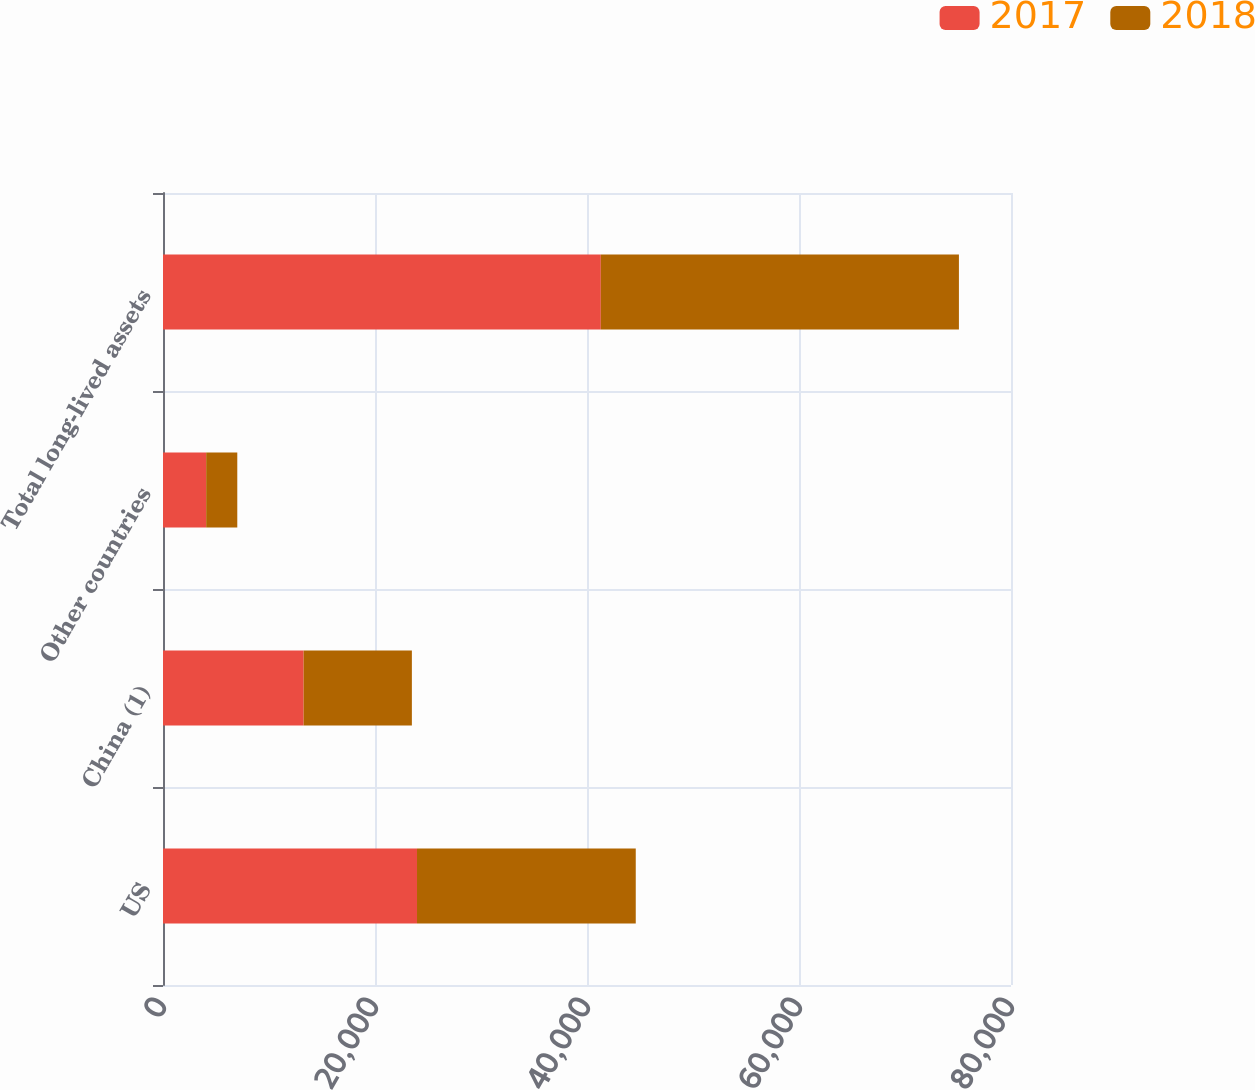<chart> <loc_0><loc_0><loc_500><loc_500><stacked_bar_chart><ecel><fcel>US<fcel>China (1)<fcel>Other countries<fcel>Total long-lived assets<nl><fcel>2017<fcel>23963<fcel>13268<fcel>4073<fcel>41304<nl><fcel>2018<fcel>20637<fcel>10211<fcel>2935<fcel>33783<nl></chart> 